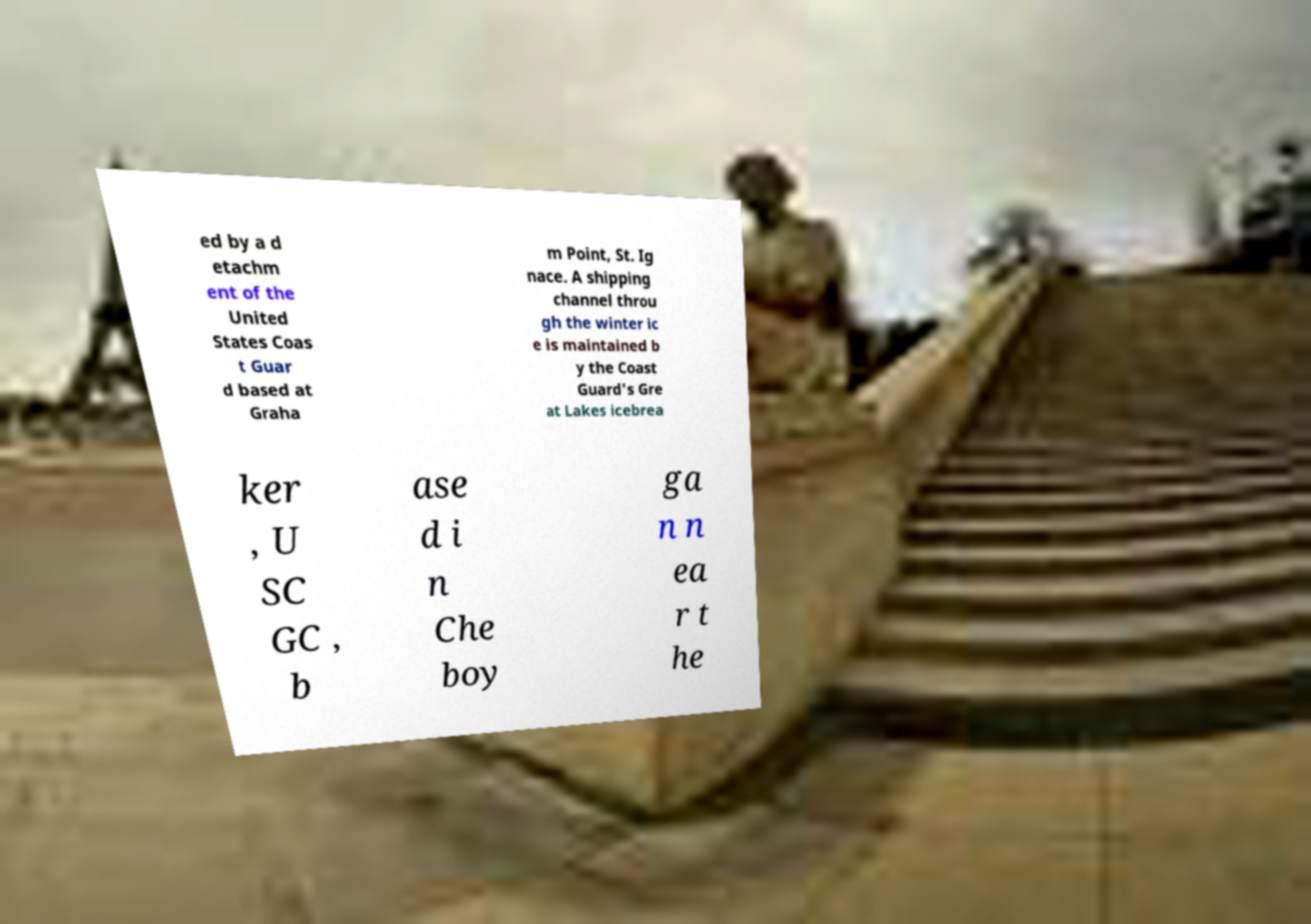What messages or text are displayed in this image? I need them in a readable, typed format. ed by a d etachm ent of the United States Coas t Guar d based at Graha m Point, St. Ig nace. A shipping channel throu gh the winter ic e is maintained b y the Coast Guard's Gre at Lakes icebrea ker , U SC GC , b ase d i n Che boy ga n n ea r t he 